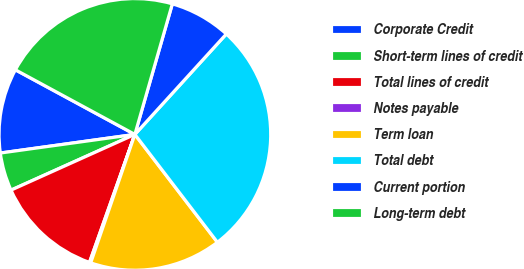Convert chart to OTSL. <chart><loc_0><loc_0><loc_500><loc_500><pie_chart><fcel>Corporate Credit<fcel>Short-term lines of credit<fcel>Total lines of credit<fcel>Notes payable<fcel>Term loan<fcel>Total debt<fcel>Current portion<fcel>Long-term debt<nl><fcel>10.08%<fcel>4.54%<fcel>12.85%<fcel>0.15%<fcel>15.67%<fcel>27.85%<fcel>7.31%<fcel>21.56%<nl></chart> 